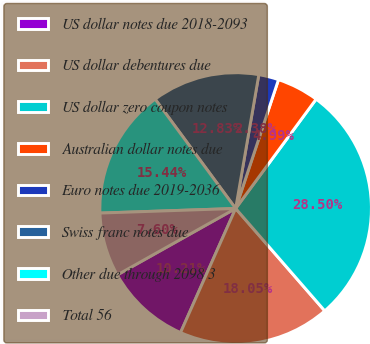<chart> <loc_0><loc_0><loc_500><loc_500><pie_chart><fcel>US dollar notes due 2018-2093<fcel>US dollar debentures due<fcel>US dollar zero coupon notes<fcel>Australian dollar notes due<fcel>Euro notes due 2019-2036<fcel>Swiss franc notes due<fcel>Other due through 2098 3<fcel>Total 56<nl><fcel>10.21%<fcel>18.05%<fcel>28.5%<fcel>4.99%<fcel>2.38%<fcel>12.83%<fcel>15.44%<fcel>7.6%<nl></chart> 